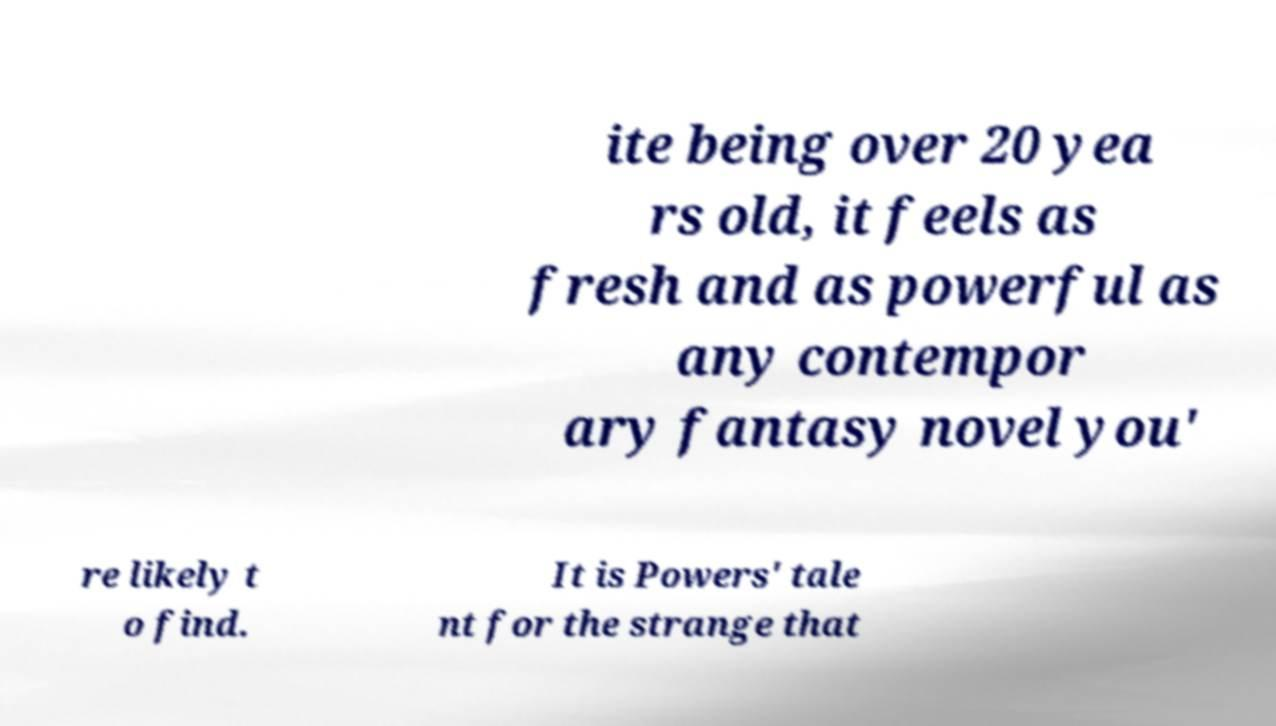Can you accurately transcribe the text from the provided image for me? ite being over 20 yea rs old, it feels as fresh and as powerful as any contempor ary fantasy novel you' re likely t o find. It is Powers' tale nt for the strange that 